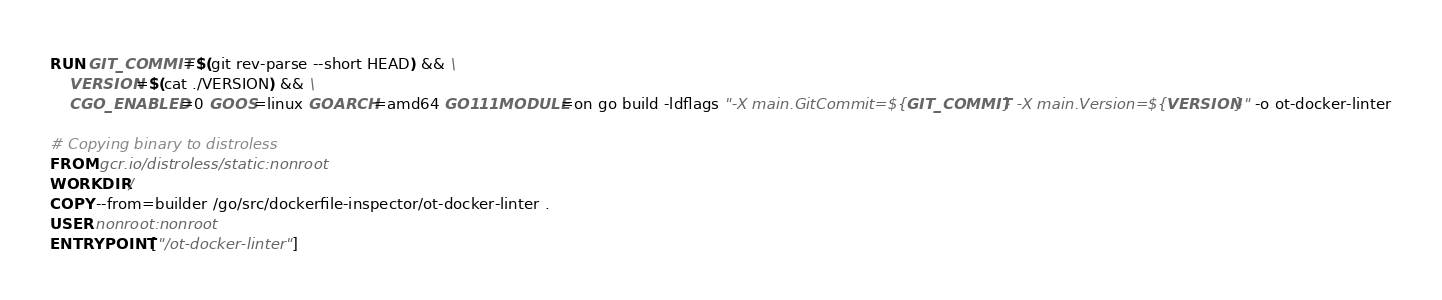<code> <loc_0><loc_0><loc_500><loc_500><_Dockerfile_>RUN GIT_COMMIT=$(git rev-parse --short HEAD) && \
    VERSION=$(cat ./VERSION) && \
    CGO_ENABLED=0 GOOS=linux GOARCH=amd64 GO111MODULE=on go build -ldflags "-X main.GitCommit=${GIT_COMMIT} -X main.Version=${VERSION}" -o ot-docker-linter

# Copying binary to distroless
FROM gcr.io/distroless/static:nonroot
WORKDIR /
COPY --from=builder /go/src/dockerfile-inspector/ot-docker-linter .
USER nonroot:nonroot
ENTRYPOINT ["/ot-docker-linter"]
</code> 